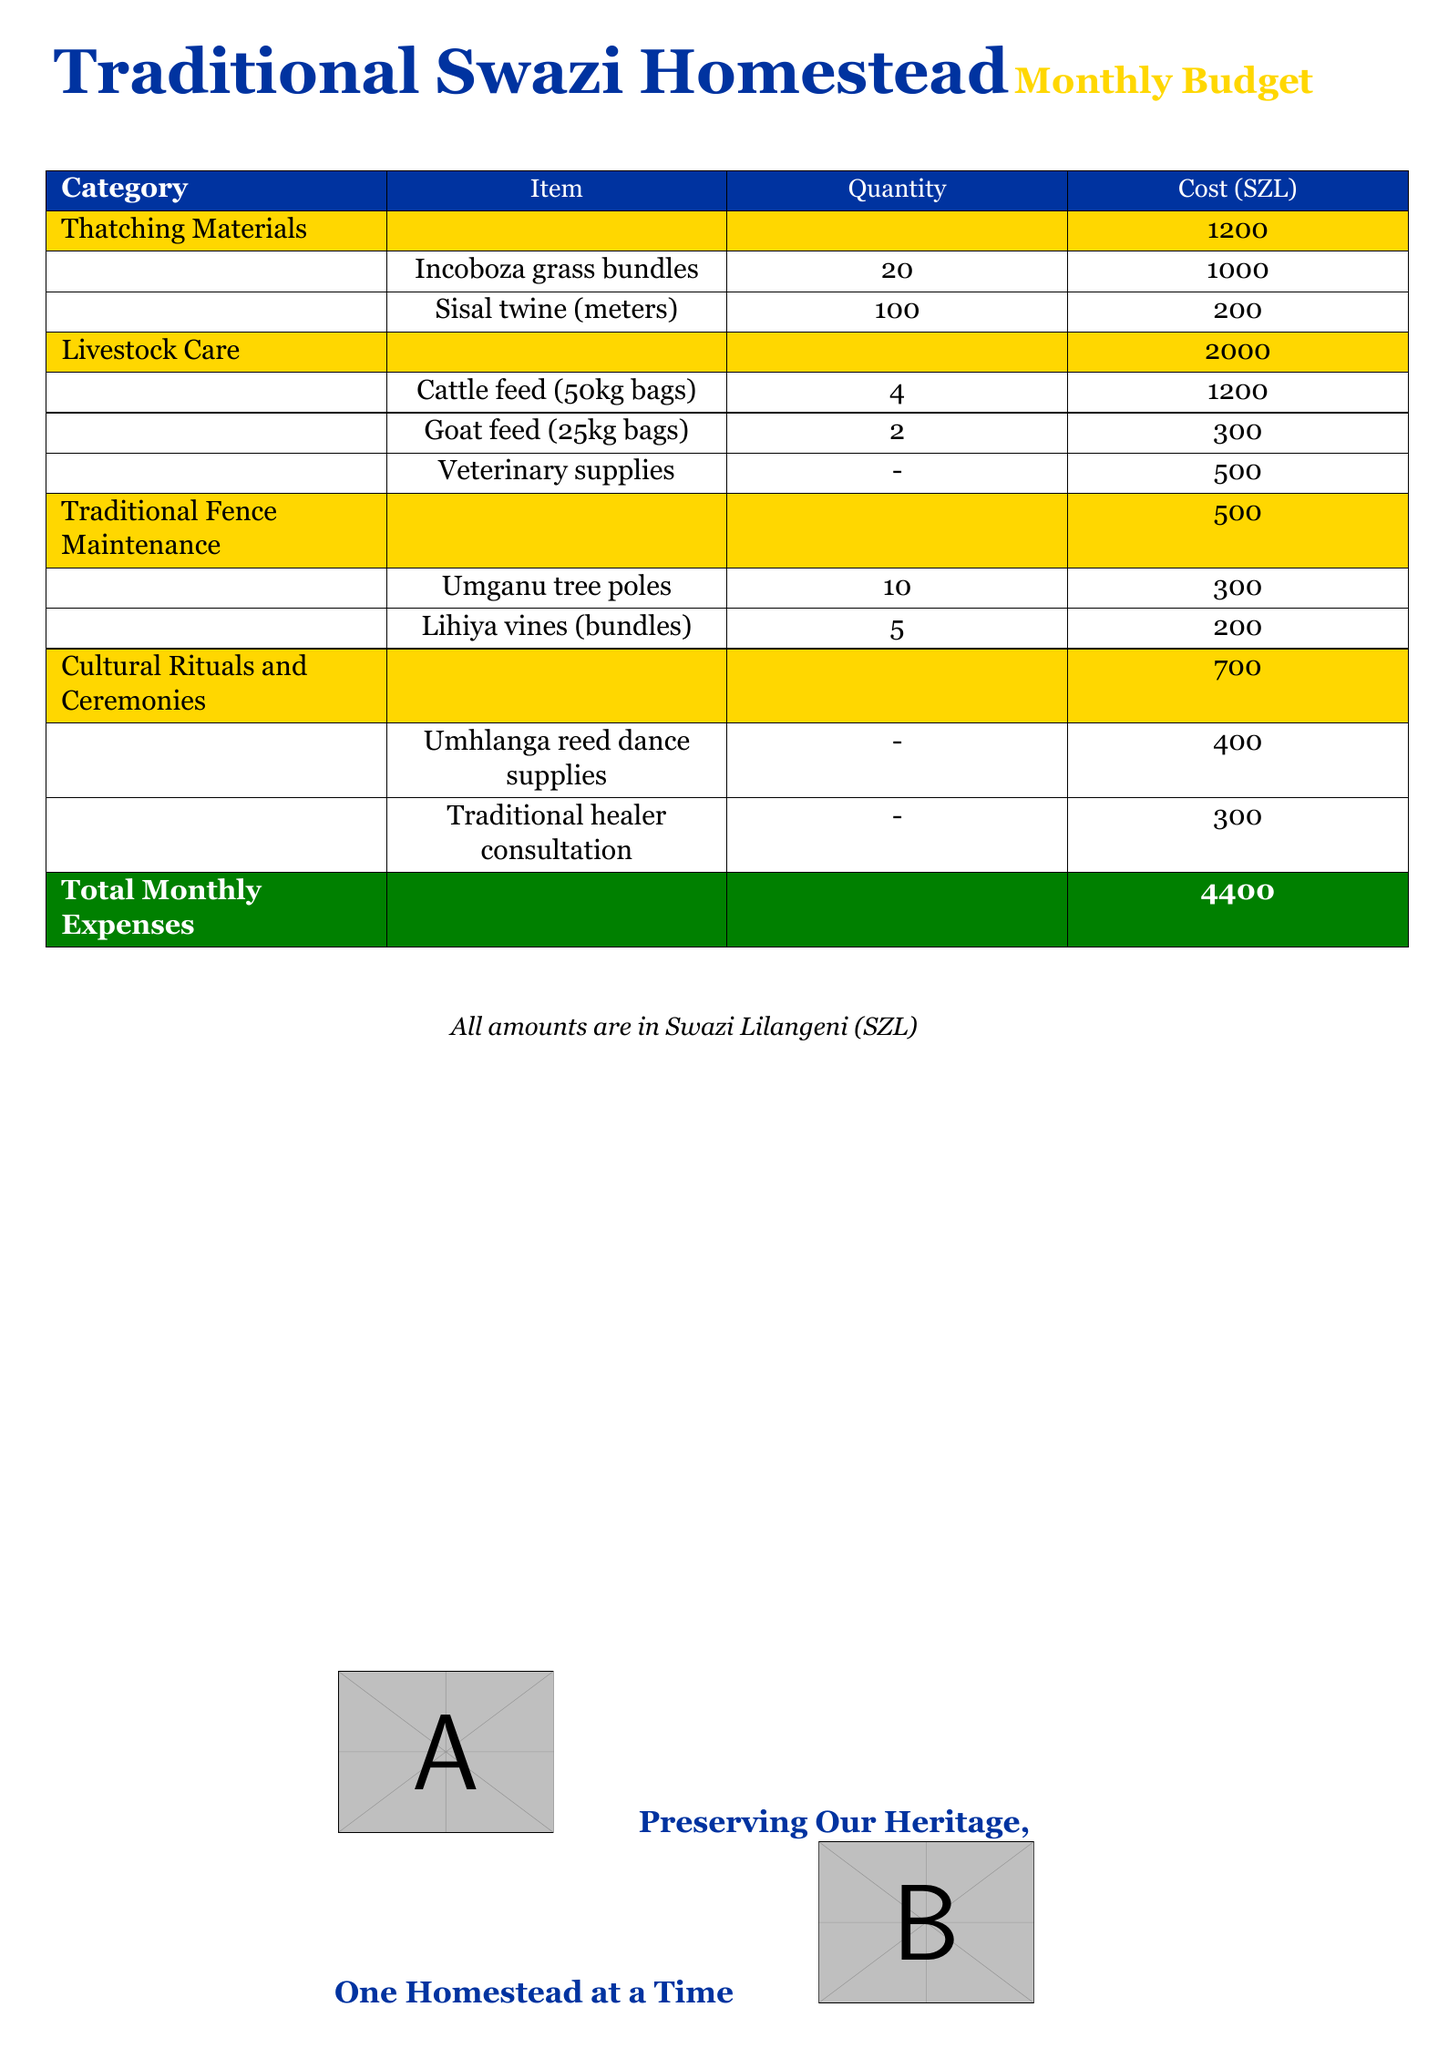What is the total monthly expense? The total monthly expense is explicitly stated at the bottom of the budget, which sums all the costs.
Answer: 4400 How much does thatching materials cost? The budget lists the total cost for thatching materials as 1200, including specific items.
Answer: 1200 What is the cost of cattle feed? The budget indicates the cost of cattle feed per quantity in the livestock care section.
Answer: 1200 How many goats' feed bags are included? The document provides a specific number of goat feed bags included in the livestock care category.
Answer: 2 What is the cost of veterinary supplies? The amount allocated for veterinary supplies in the livestock care section of the budget is given.
Answer: 500 How many incoboza grass bundles are needed? The budget lists the quantity needed for incoboza grass bundles under thatching materials.
Answer: 20 What are the supplies for the Umhlanga reed dance? The budget specifically states the cost of supplies needed for the Umhlanga reed dance in cultural rituals.
Answer: 400 What type of tree poles are listed for fence maintenance? The types of tree poles are mentioned explicitly in the traditional fence maintenance section of the budget.
Answer: Umganu tree poles How many Lihiya vines bundles are required? The budget details the number of Lihiya vines bundles needed for traditional fence maintenance.
Answer: 5 